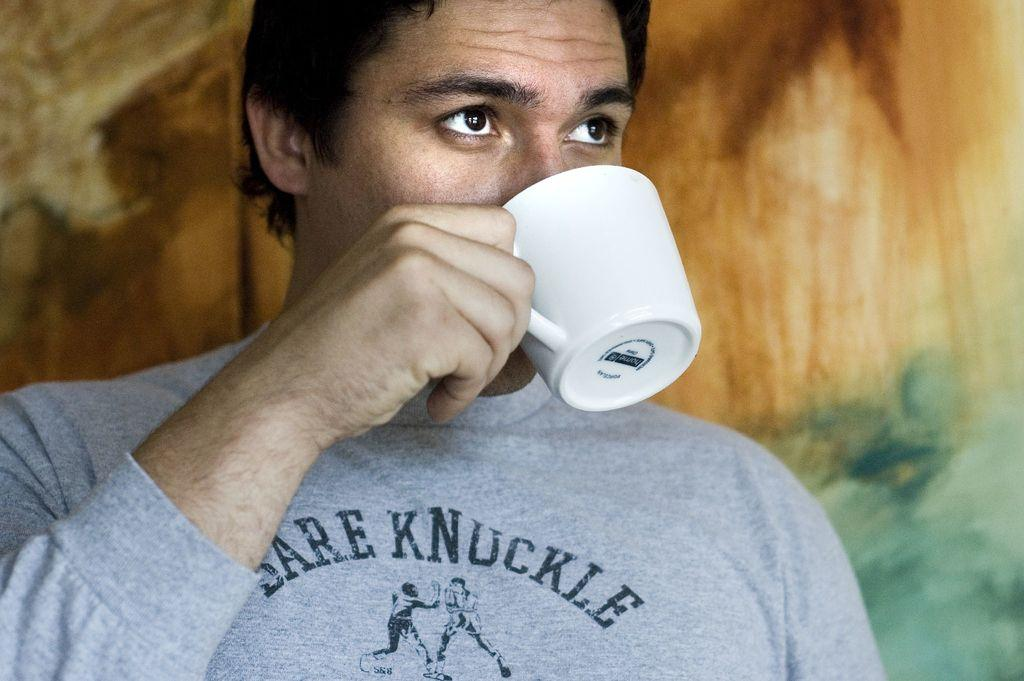Who or what is present in the image? There is a person in the image. What is the person doing in the image? The person is drinking a cup of tea. How much of the person is visible in the image? The person is only half visible. What can be seen in the background of the image? There is a wall painting visible in the background. Where might this image have been taken? The image appears to be taken inside a hall. What type of iron can be seen in the image? There is no iron present in the image. How many cars are visible in the image? There are no cars visible in the image. 